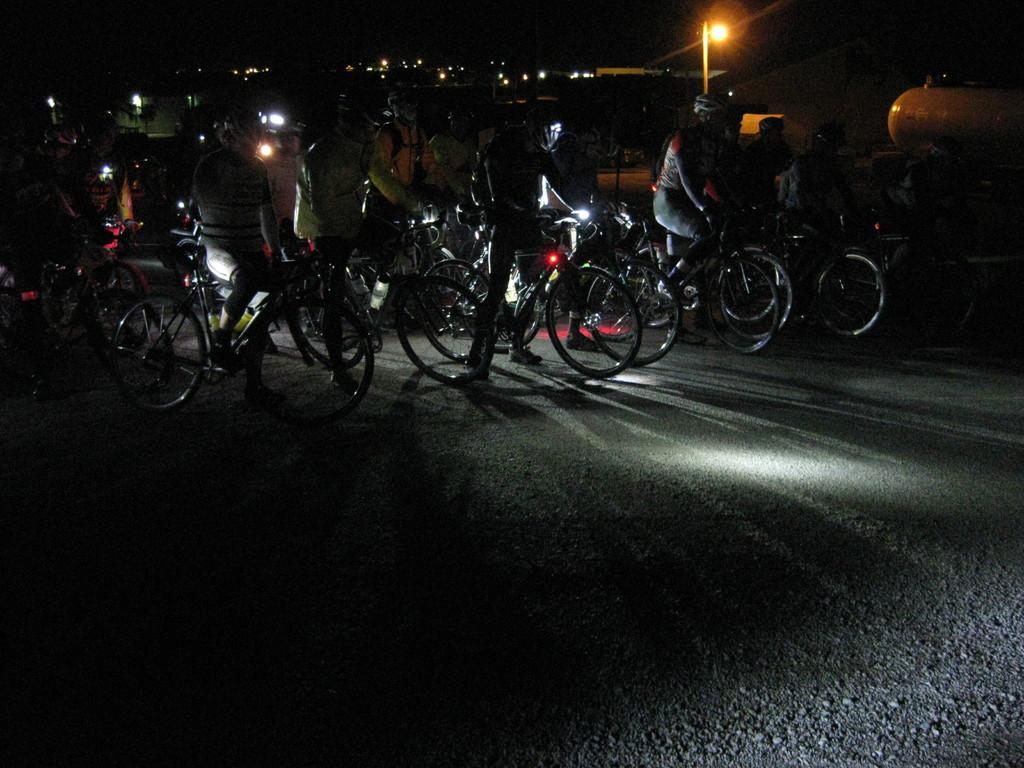Describe this image in one or two sentences. In this image I can see group of people on bicycles, also they are wearing helmets. There are lights and there is a dark background. 